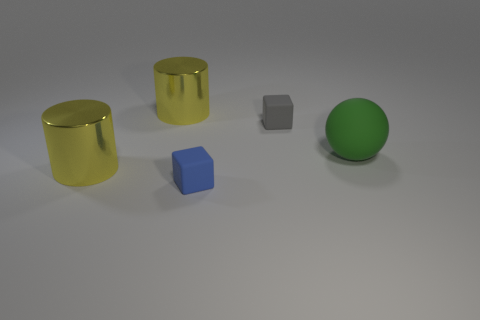Do the gray thing and the green rubber ball have the same size?
Offer a very short reply. No. Is there another matte thing of the same size as the green matte thing?
Ensure brevity in your answer.  No. What is the cube that is behind the big green matte sphere made of?
Provide a short and direct response. Rubber. The other block that is made of the same material as the blue block is what color?
Your answer should be very brief. Gray. What number of rubber things are large yellow objects or big spheres?
Your answer should be compact. 1. How many objects are big metal objects that are in front of the gray cube or things behind the large green matte ball?
Your answer should be compact. 3. There is a gray thing that is the same size as the blue thing; what is its material?
Make the answer very short. Rubber. Is the number of rubber cubes to the left of the big matte object the same as the number of large yellow cylinders to the right of the small gray rubber object?
Keep it short and to the point. No. How many green objects are cylinders or large balls?
Offer a terse response. 1. There is a rubber ball; is it the same color as the small block behind the large green object?
Keep it short and to the point. No. 